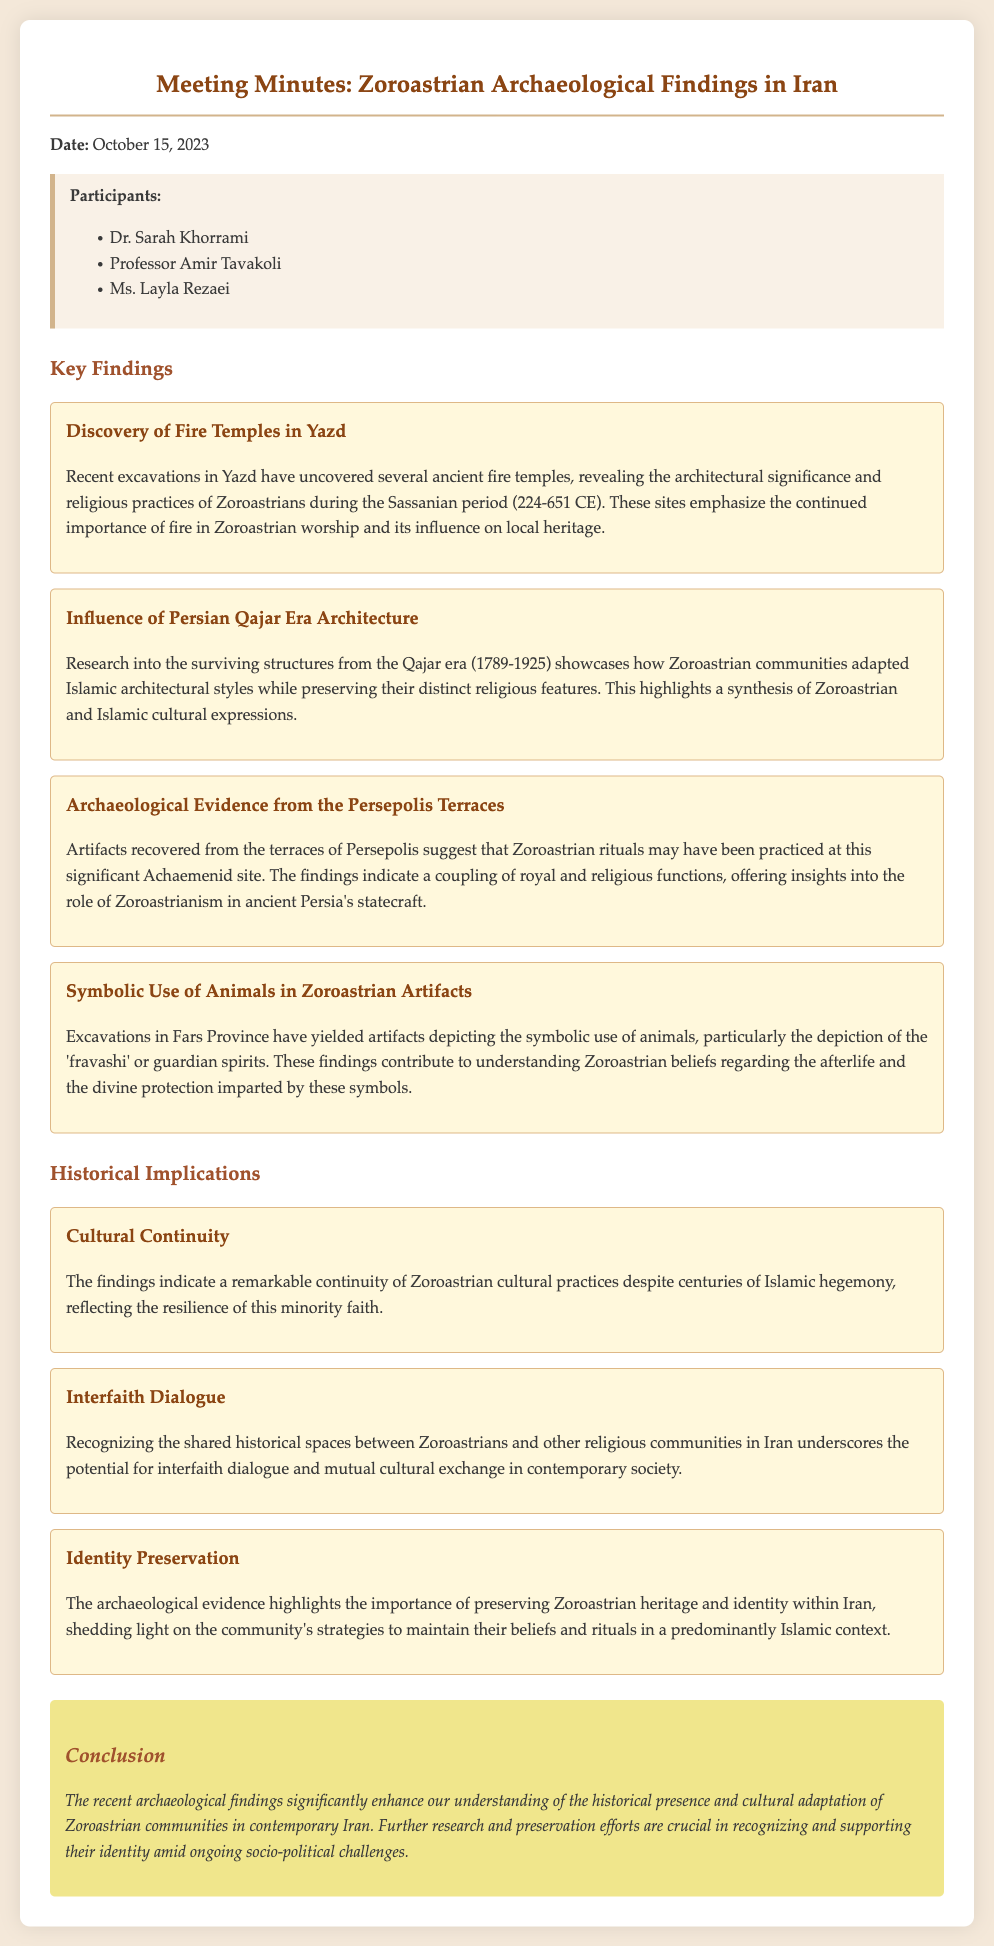What date was the meeting held? The date of the meeting is explicitly stated in the document.
Answer: October 15, 2023 Who discovered the fire temples in Yazd? The minutes list the participants but do not specify who made the discovery.
Answer: Not specified What period do the fire temples date back to? The document mentions the Sassanian period in connection with the fire temples.
Answer: Sassanian period (224-651 CE) What does the symbolic use of animals relate to in Zoroastrian beliefs? The findings discuss guardian spirits, which are significant in Zoroastrian beliefs about the afterlife.
Answer: Afterlife What is a key implication of the archaeological findings regarding cultural practices? One of the implications is about cultural continuity in Zoroastrian practices despite challenges.
Answer: Cultural continuity Which architectural era showcases Zoroastrian adaptations? The document refers to the specific era where Zoroastrians adapted certain styles.
Answer: Qajar era (1789-1925) What kind of dialogue is suggested by recognizing shared historical spaces? The implications discuss the potential for this type of dialogue among religious communities in Iran.
Answer: Interfaith dialogue What is emphasized as crucial for Zoroastrian communities facing socio-political challenges? The conclusion mentions a necessity related to the community's identity preservation efforts.
Answer: Preservation efforts 